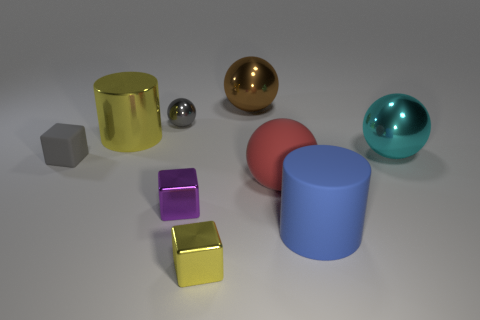Subtract all spheres. How many objects are left? 5 Subtract 1 gray cubes. How many objects are left? 8 Subtract all big yellow things. Subtract all red matte spheres. How many objects are left? 7 Add 1 large red matte spheres. How many large red matte spheres are left? 2 Add 3 big green cubes. How many big green cubes exist? 3 